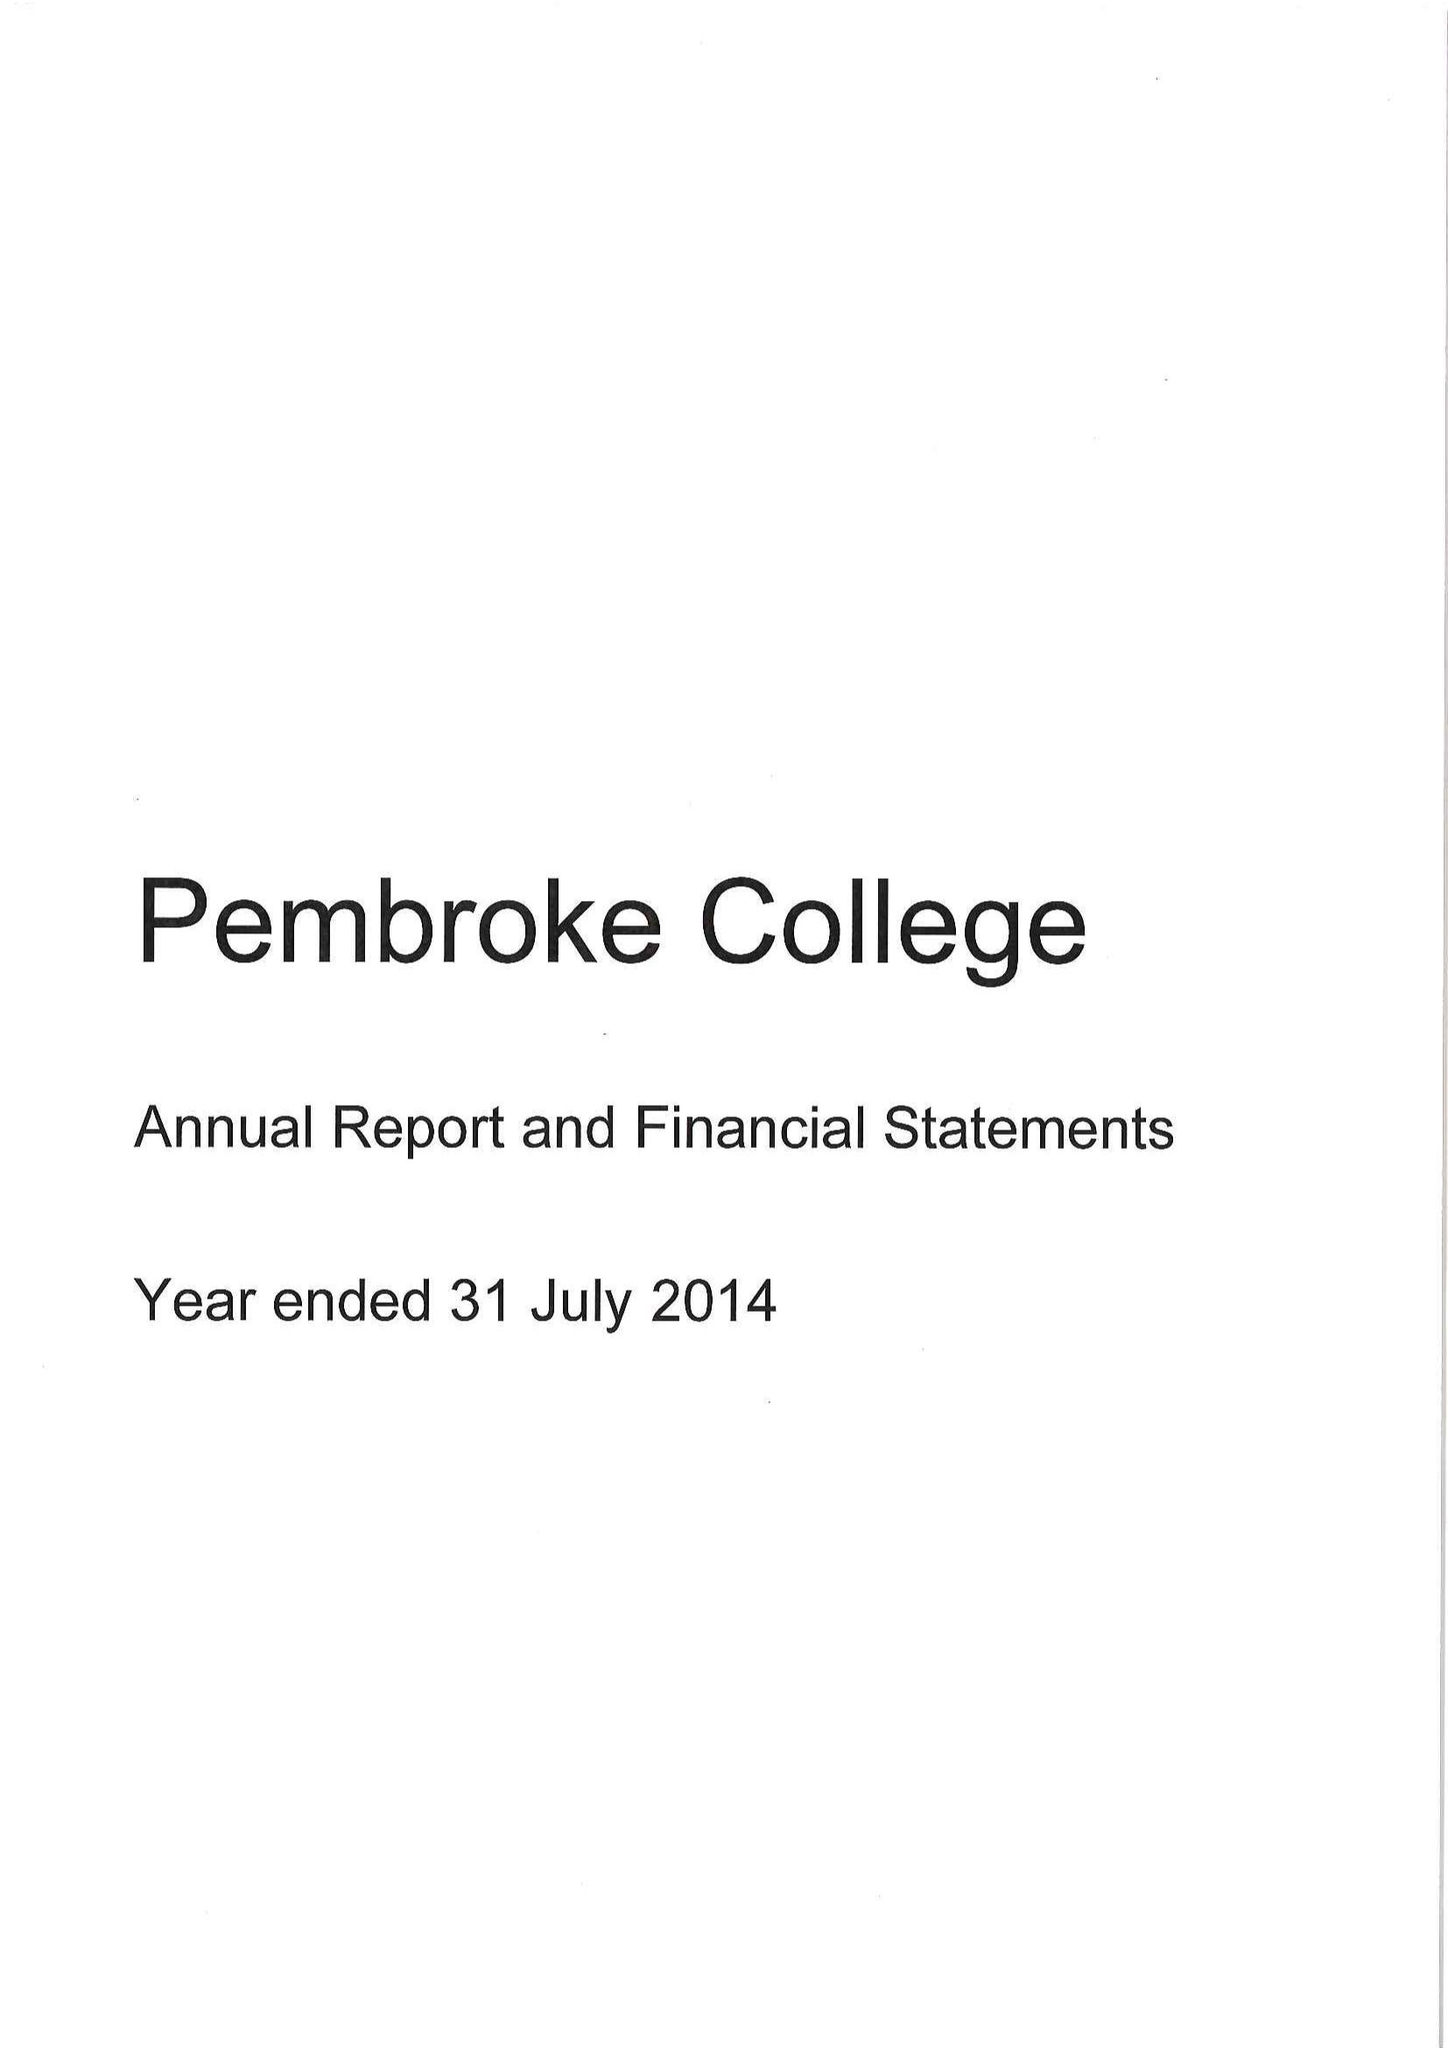What is the value for the address__street_line?
Answer the question using a single word or phrase. ST ALDATES 